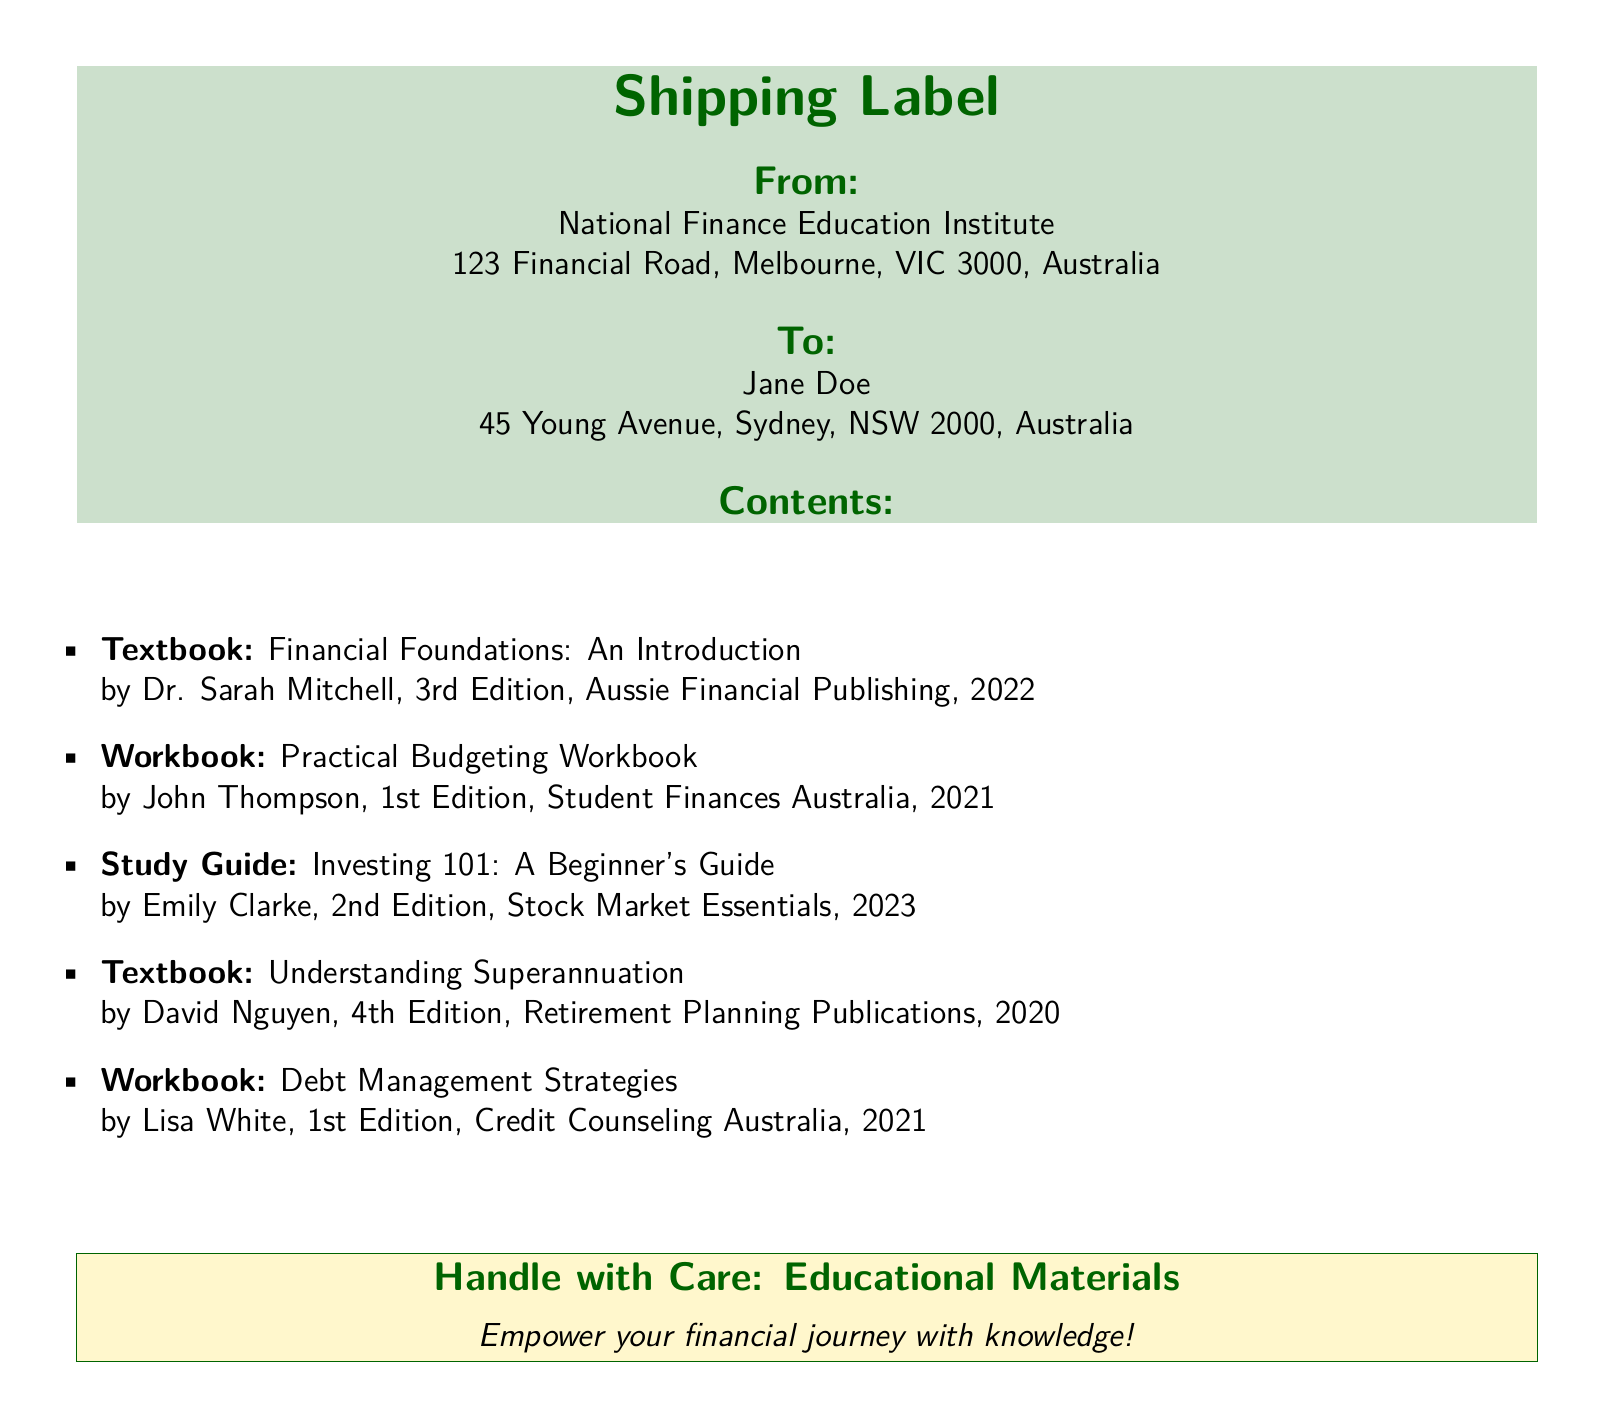What is the sender's name? The sender's name is mentioned at the top as National Finance Education Institute.
Answer: National Finance Education Institute What is the recipient's address? The recipient's address is listed clearly under the "To" section.
Answer: 45 Young Avenue, Sydney, NSW 2000, Australia Who is the author of "Financial Foundations: An Introduction"? The document lists the author of this textbook among the contents.
Answer: Dr. Sarah Mitchell What is the edition of "Understanding Superannuation"? The edition is specified next to the title of this textbook.
Answer: 4th Edition How many items are included in the shipment? By counting the number of bullet points in the contents section, we can find this information.
Answer: 5 What is the title of the workbook authored by John Thompson? The title is directly listed with the author's name in the contents section.
Answer: Practical Budgeting Workbook Which organization published "Investing 101: A Beginner's Guide"? The publisher's name is included alongside the title in the document.
Answer: Stock Market Essentials What color is used for the "Shipping Label" text? The document specifies the color used for this title.
Answer: Austrlian green What is the message on the "Handle with Care" section? This section contains a motivational phrase encouraging education.
Answer: Empower your financial journey with knowledge! 